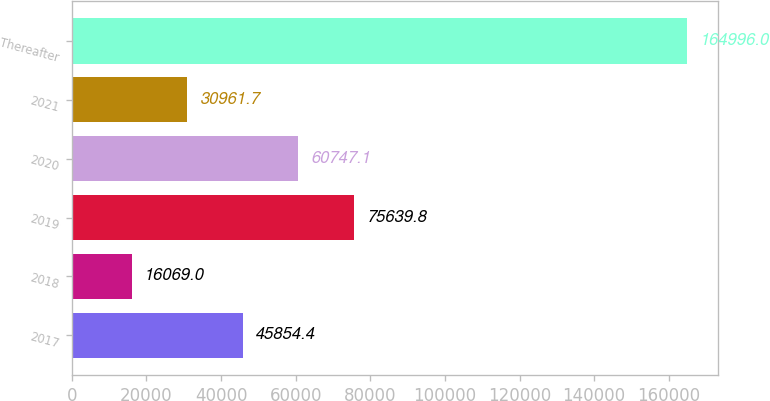Convert chart. <chart><loc_0><loc_0><loc_500><loc_500><bar_chart><fcel>2017<fcel>2018<fcel>2019<fcel>2020<fcel>2021<fcel>Thereafter<nl><fcel>45854.4<fcel>16069<fcel>75639.8<fcel>60747.1<fcel>30961.7<fcel>164996<nl></chart> 